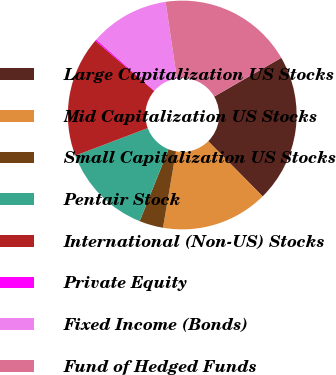Convert chart. <chart><loc_0><loc_0><loc_500><loc_500><pie_chart><fcel>Large Capitalization US Stocks<fcel>Mid Capitalization US Stocks<fcel>Small Capitalization US Stocks<fcel>Pentair Stock<fcel>International (Non-US) Stocks<fcel>Private Equity<fcel>Fixed Income (Bonds)<fcel>Fund of Hedged Funds<nl><fcel>20.93%<fcel>15.1%<fcel>3.38%<fcel>13.15%<fcel>17.04%<fcel>0.21%<fcel>11.21%<fcel>18.99%<nl></chart> 